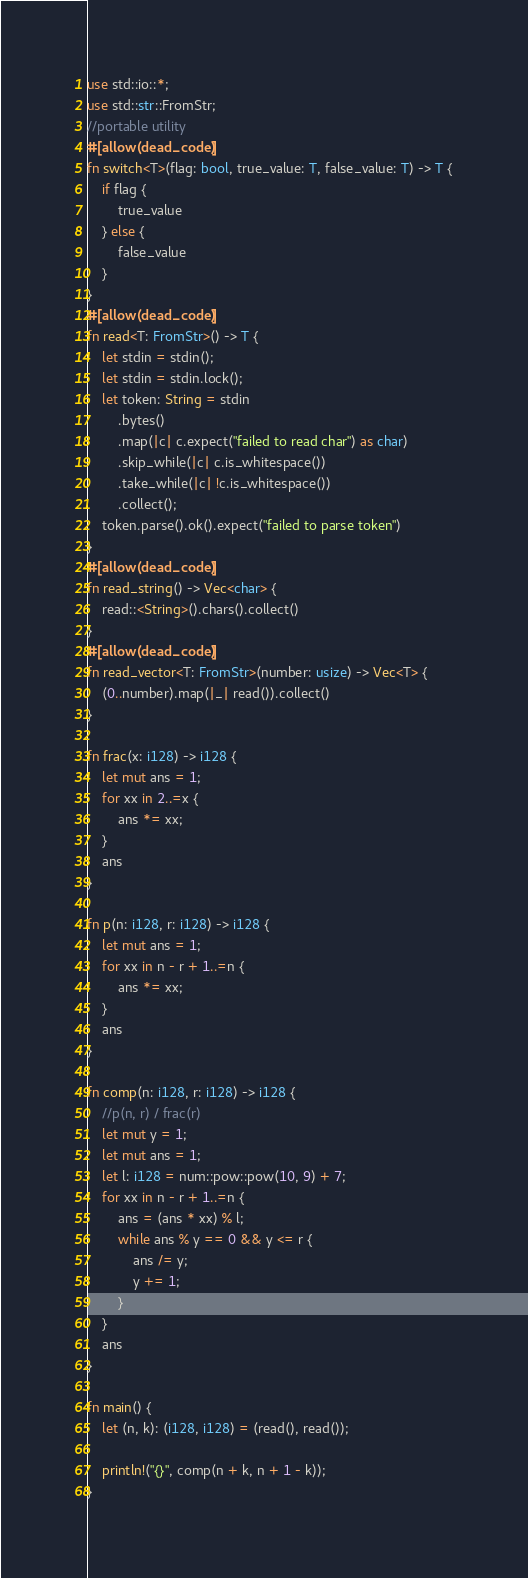Convert code to text. <code><loc_0><loc_0><loc_500><loc_500><_Rust_>use std::io::*;
use std::str::FromStr;
//portable utility
#[allow(dead_code)]
fn switch<T>(flag: bool, true_value: T, false_value: T) -> T {
    if flag {
        true_value
    } else {
        false_value
    }
}
#[allow(dead_code)]
fn read<T: FromStr>() -> T {
    let stdin = stdin();
    let stdin = stdin.lock();
    let token: String = stdin
        .bytes()
        .map(|c| c.expect("failed to read char") as char)
        .skip_while(|c| c.is_whitespace())
        .take_while(|c| !c.is_whitespace())
        .collect();
    token.parse().ok().expect("failed to parse token")
}
#[allow(dead_code)]
fn read_string() -> Vec<char> {
    read::<String>().chars().collect()
}
#[allow(dead_code)]
fn read_vector<T: FromStr>(number: usize) -> Vec<T> {
    (0..number).map(|_| read()).collect()
}

fn frac(x: i128) -> i128 {
    let mut ans = 1;
    for xx in 2..=x {
        ans *= xx;
    }
    ans
}

fn p(n: i128, r: i128) -> i128 {
    let mut ans = 1;
    for xx in n - r + 1..=n {
        ans *= xx;
    }
    ans
}

fn comp(n: i128, r: i128) -> i128 {
    //p(n, r) / frac(r)
    let mut y = 1;
    let mut ans = 1;
    let l: i128 = num::pow::pow(10, 9) + 7;
    for xx in n - r + 1..=n {
        ans = (ans * xx) % l;
        while ans % y == 0 && y <= r {
            ans /= y;
            y += 1;
        }
    }
    ans
}

fn main() {
    let (n, k): (i128, i128) = (read(), read());

    println!("{}", comp(n + k, n + 1 - k));
}
</code> 